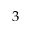Convert formula to latex. <formula><loc_0><loc_0><loc_500><loc_500>3</formula> 